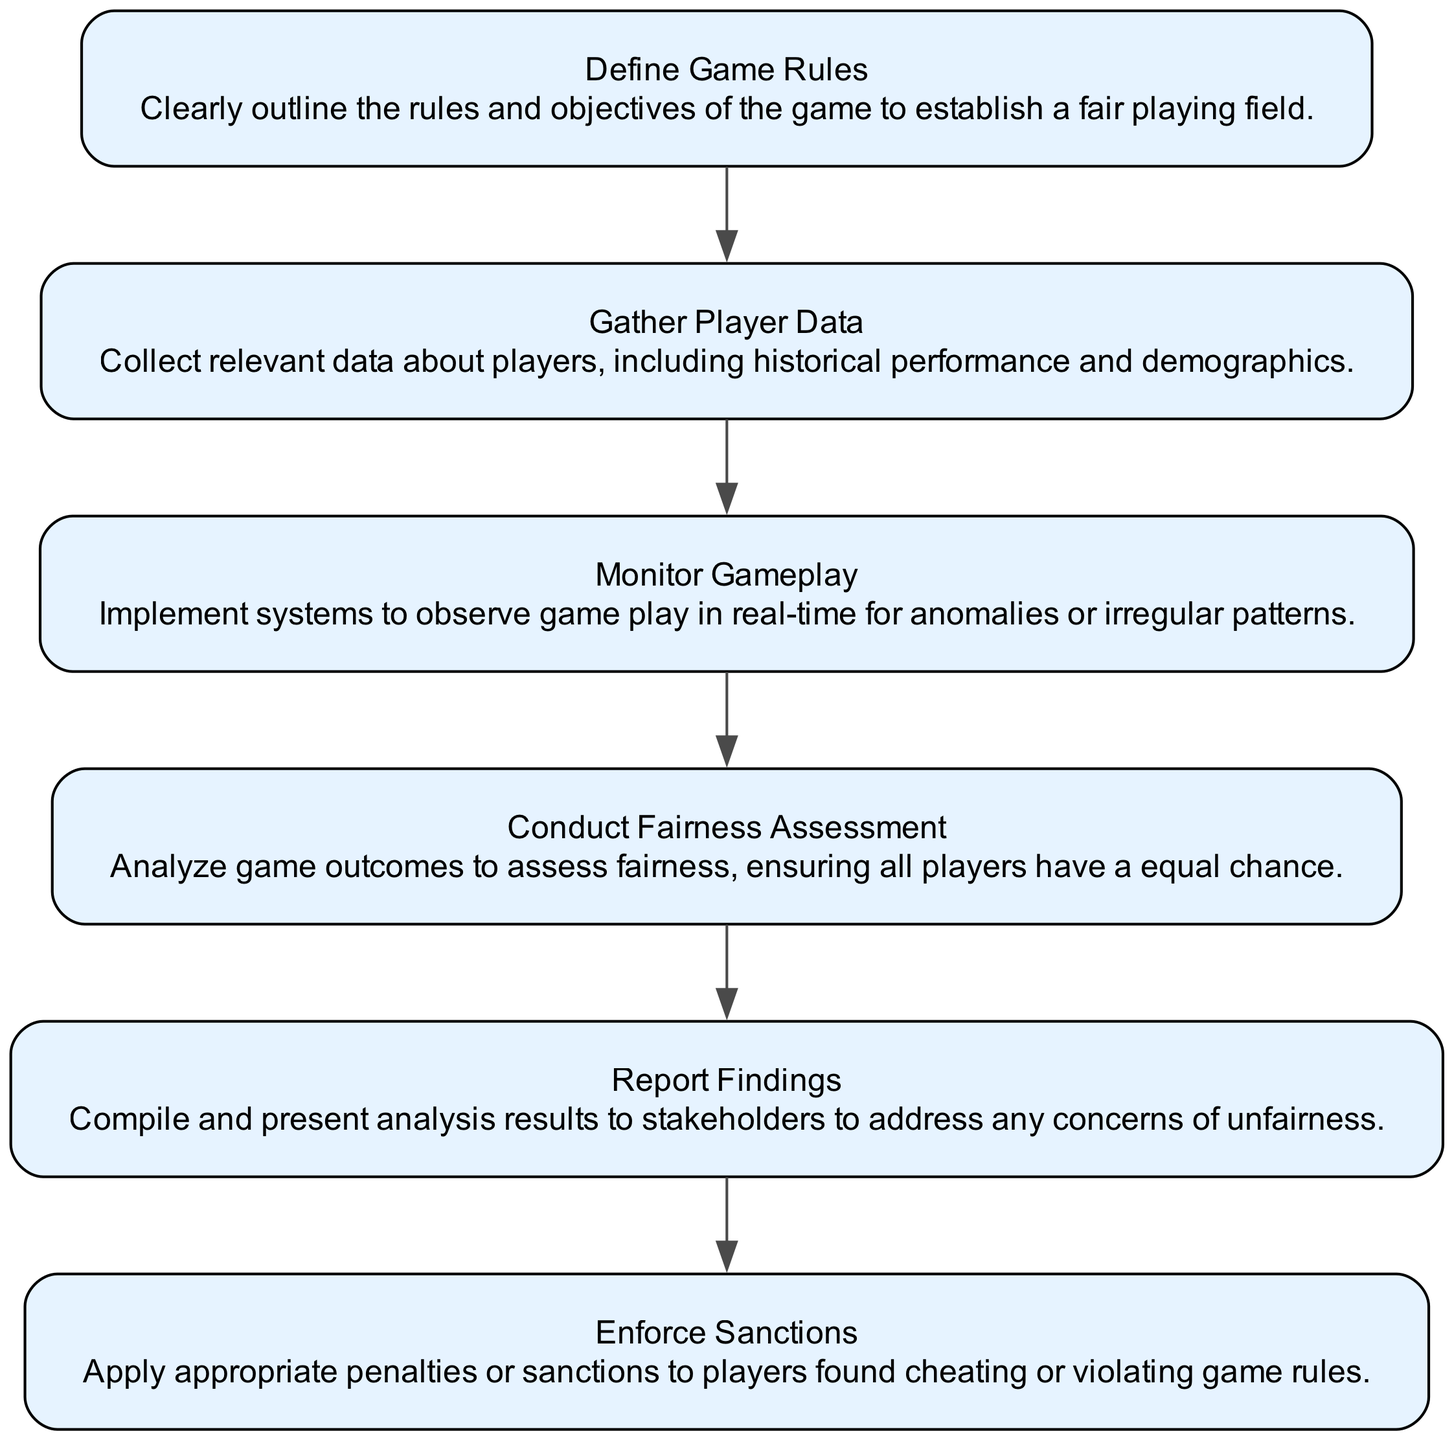What is the first step in the workflow? The first step in the workflow is defining the game rules, as indicated by the first node in the flowchart.
Answer: Define Game Rules How many nodes are present in the diagram? By counting each of the elements listed, we find there are six distinct nodes in the diagram.
Answer: 6 Which node follows the "Monitor Gameplay" step? The "Conduct Fairness Assessment" step directly follows "Monitor Gameplay," as shown in the flow of the diagram.
Answer: Conduct Fairness Assessment What is the last action taken in the workflow? The last action taken is to enforce sanctions, which is represented as the final node in the flowchart.
Answer: Enforce Sanctions Which nodes are directly connected to the "Gather Player Data"? The nodes connected to "Gather Player Data" include "Monitor Gameplay" as the subsequent action, reflecting the flow direction from this node.
Answer: Monitor Gameplay What are the two main actions involved after monitoring gameplay? After monitoring gameplay, the two main actions are “Conduct Fairness Assessment” and “Report Findings,” indicating a sequence of analysis and communication.
Answer: Conduct Fairness Assessment, Report Findings What kind of assessment is performed after gathering player data? The assessment performed after gathering player data is a fairness assessment, aimed at evaluating game outcomes based on the earlier collected player data.
Answer: Conduct Fairness Assessment Which step involves observing real-time gameplay? The step that involves observing real-time gameplay is "Monitor Gameplay," which focuses specifically on this aspect of the workflow.
Answer: Monitor Gameplay 